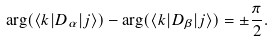Convert formula to latex. <formula><loc_0><loc_0><loc_500><loc_500>\arg ( \langle k | D _ { \alpha } | j \rangle ) - \arg ( \langle k | D _ { \beta } | j \rangle ) = \pm \frac { \pi } { 2 } .</formula> 